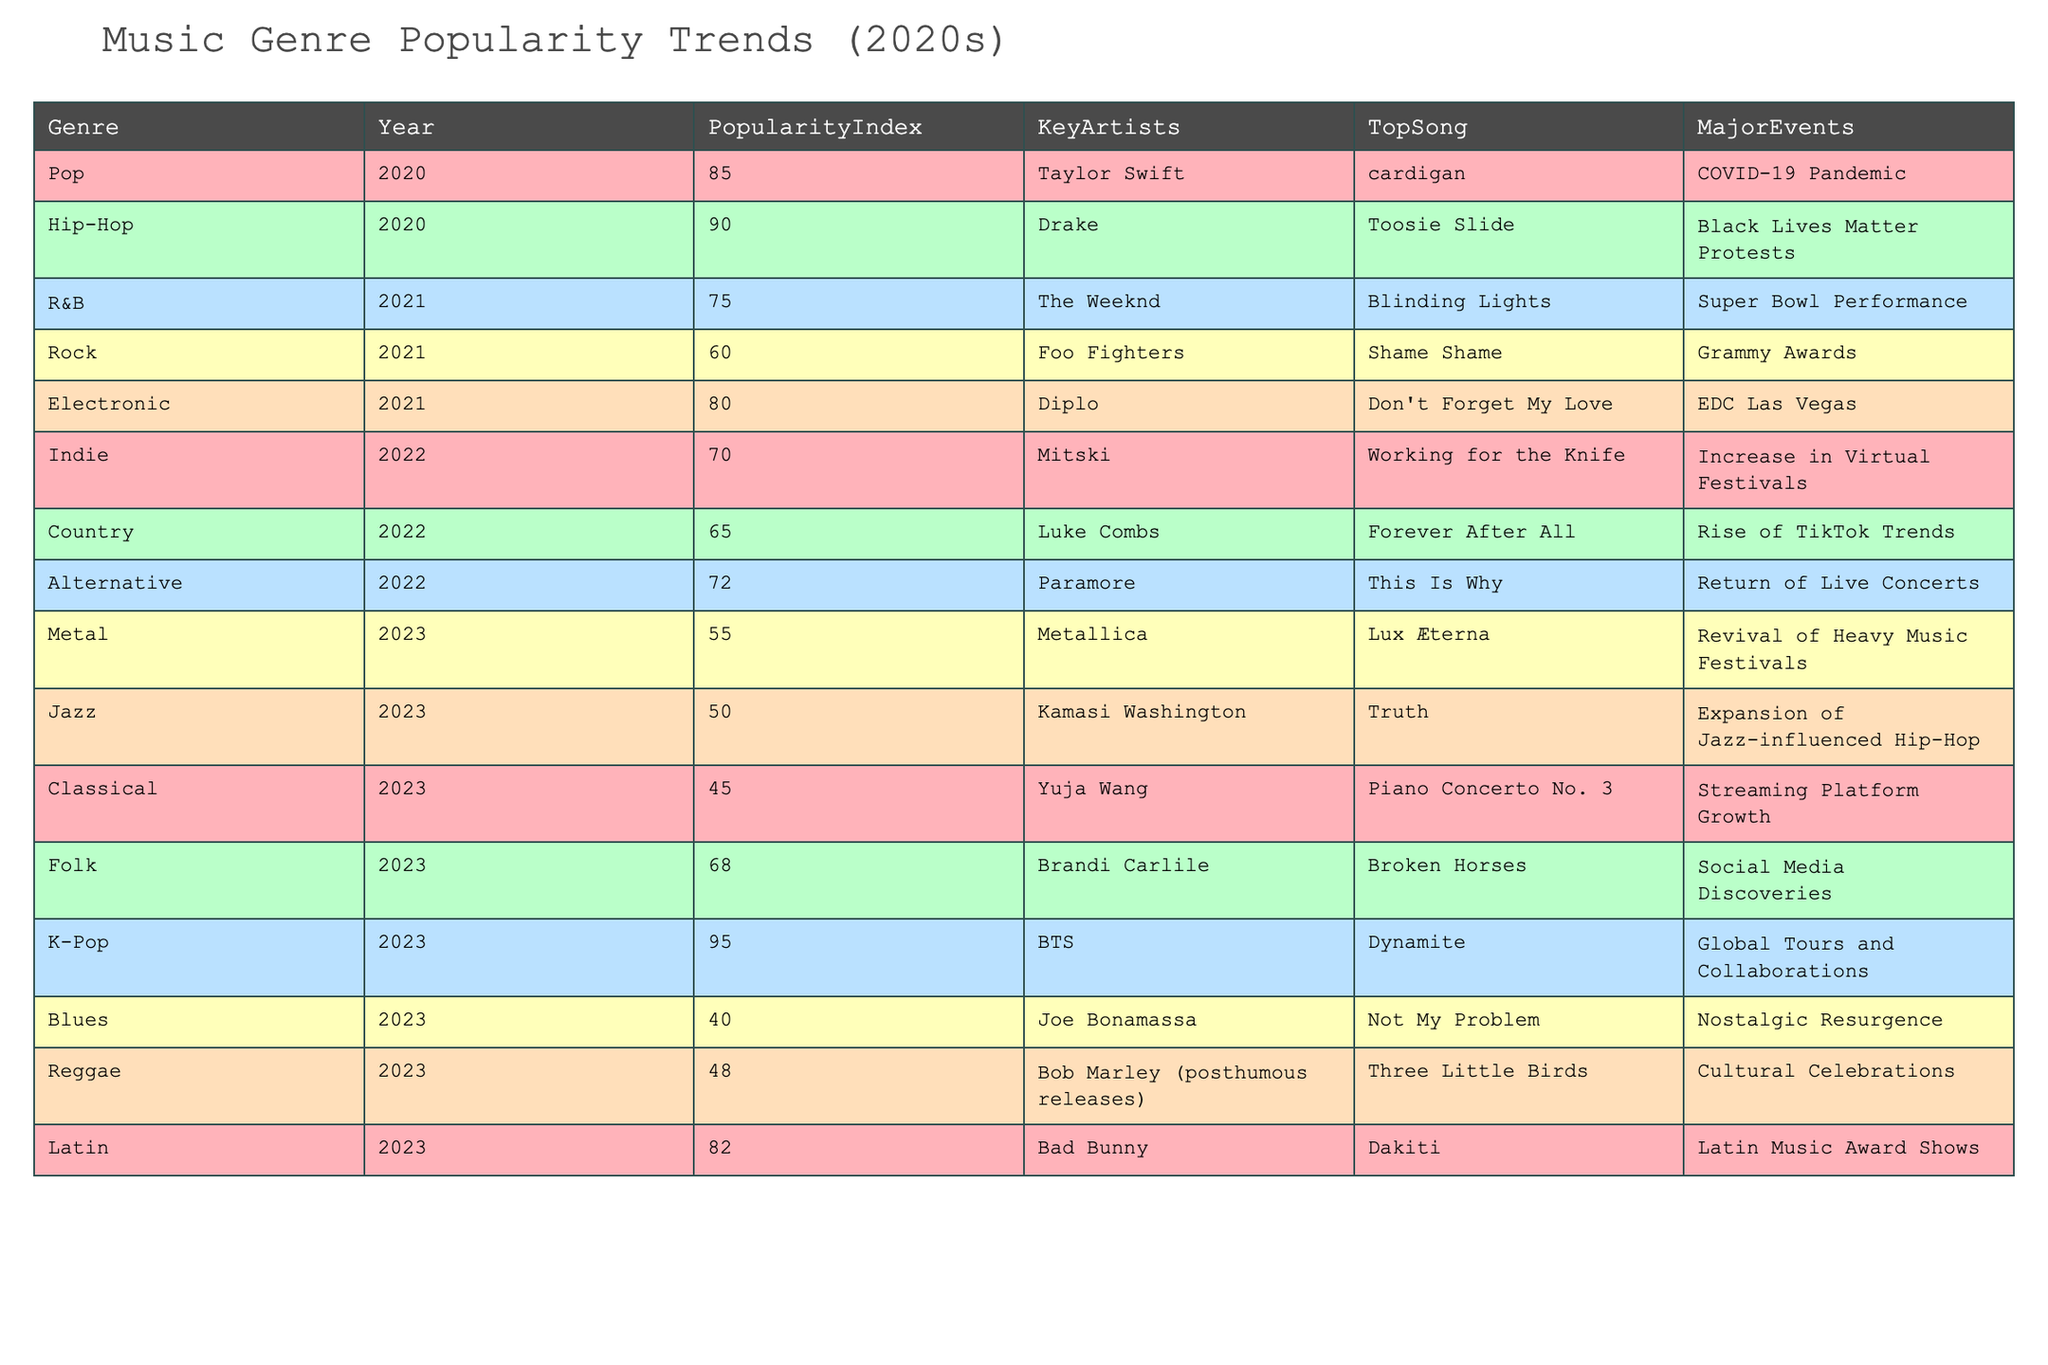What was the popularity index for Hip-Hop in 2020? The table indicates that the popularity index for Hip-Hop in 2020 is listed directly. Looking at the row for Hip-Hop, we see a popularity index of 90.
Answer: 90 Which genre had the highest popularity index in 2023? To find this, we compare the popularity indices of all genres in 2023. K-Pop has a popularity index of 95, which is higher than any other genre listed for that year.
Answer: K-Pop Is the top song for R&B in 2021 "Blinding Lights"? The table clearly states that the top song for R&B in 2021 is "Blinding Lights". Therefore, this statement is true.
Answer: Yes What is the average popularity index for genres in 2022? To calculate the average for 2022, we take the popularity indices for the genres listed in that year: Country (65), Indie (70), and Alternative (72), sum them up (65 + 70 + 72 = 207) and divide by the total genres (3). 207 / 3 = 69.
Answer: 69 Which genre saw a decrease in popularity from 2021 to 2023? We compare the popularity indices for the years: Rock (60 in 2021), Metal (55 in 2023), and Jazz (50 in 2023). Both Rock and Metal show a decrease, but Jazz's index also indicates a decline from its previous state. Rock declines by 5 (60 to 55) while Jazz declines by 10 (60 to 50). Therefore, Rock and Metal both saw a decrease.
Answer: Rock and Metal What major event coincided with the rise in popularity for Electronic music in 2021? Referring to the table, it states that the major event for Electronic music in 2021 was the EDC Las Vegas. This identifies a direct cause associated with the popularity of the genre that year.
Answer: EDC Las Vegas Was the top artist for Folk in 2023 involved in traditional Folk music? The top artist listed is Brandi Carlile, who is known for a more contemporary approach to Folk music, blending various influences rather than strictly adhering to traditional forms. Therefore, the answer is no.
Answer: No Identify the genre with the lowest popularity index in 2023. By examining the popularity indices of all genres for 2023, we see that Blues has the lowest index at 40, which is below that of Jazz (50), Classical (45), and Reggae (48).
Answer: Blues How many genres had a popularity index above 70 in 2022? The genres in 2022 are Country (65), Indie (70), and Alternative (72). Only Alternative exceeds an index of 70. Thus, there is only one genre with a popularity index above that threshold in 2022.
Answer: 1 